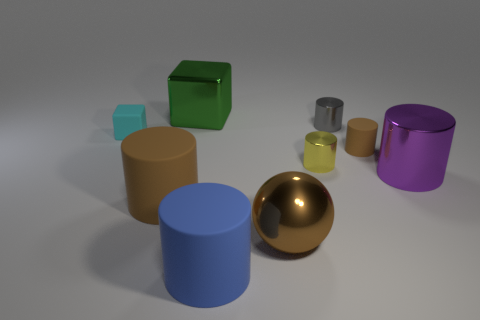Is there anything else that is the same shape as the big brown shiny thing?
Your answer should be very brief. No. Does the tiny matte thing right of the large metal block have the same color as the big metallic ball?
Keep it short and to the point. Yes. How many things are big things in front of the large metallic block or large green cubes?
Make the answer very short. 5. What material is the brown cylinder that is behind the brown cylinder that is left of the brown matte thing that is behind the purple metallic cylinder made of?
Provide a short and direct response. Rubber. Is the number of big cylinders in front of the big purple cylinder greater than the number of gray objects that are on the left side of the large brown ball?
Offer a very short reply. Yes. What number of blocks are small gray metal things or blue things?
Your answer should be compact. 0. What number of gray cylinders are to the right of the big cylinder that is left of the large matte thing on the right side of the green metallic block?
Your answer should be very brief. 1. What is the material of the big cylinder that is the same color as the large sphere?
Ensure brevity in your answer.  Rubber. Are there more big brown balls than red shiny cylinders?
Your response must be concise. Yes. Do the yellow metal object and the cyan matte cube have the same size?
Provide a succinct answer. Yes. 